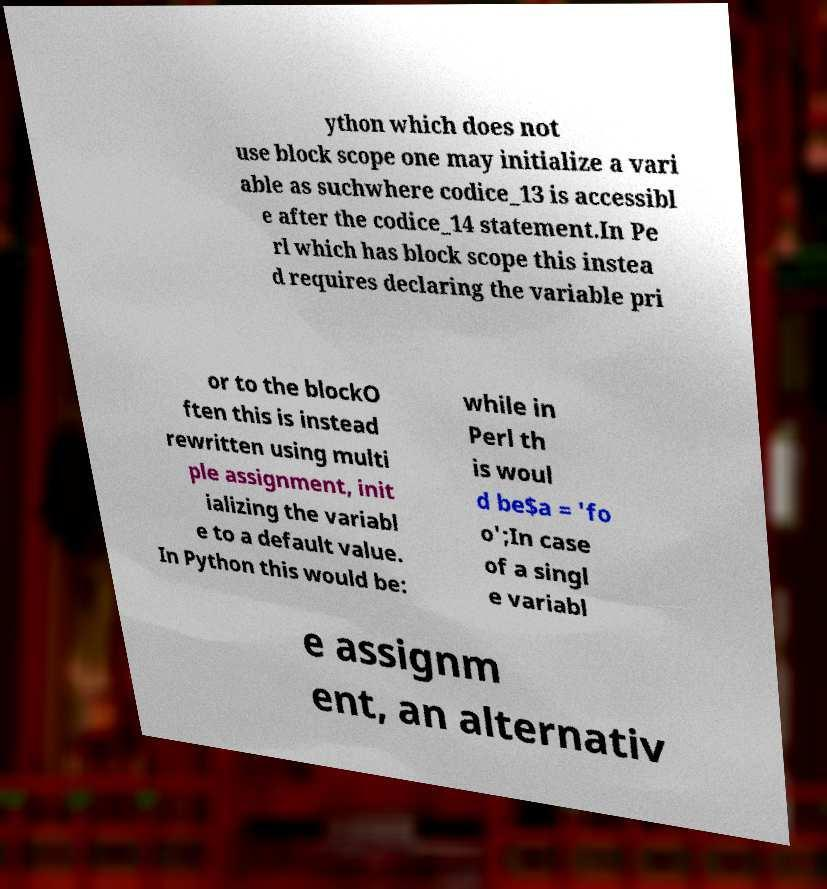Can you read and provide the text displayed in the image?This photo seems to have some interesting text. Can you extract and type it out for me? ython which does not use block scope one may initialize a vari able as suchwhere codice_13 is accessibl e after the codice_14 statement.In Pe rl which has block scope this instea d requires declaring the variable pri or to the blockO ften this is instead rewritten using multi ple assignment, init ializing the variabl e to a default value. In Python this would be: while in Perl th is woul d be$a = 'fo o';In case of a singl e variabl e assignm ent, an alternativ 